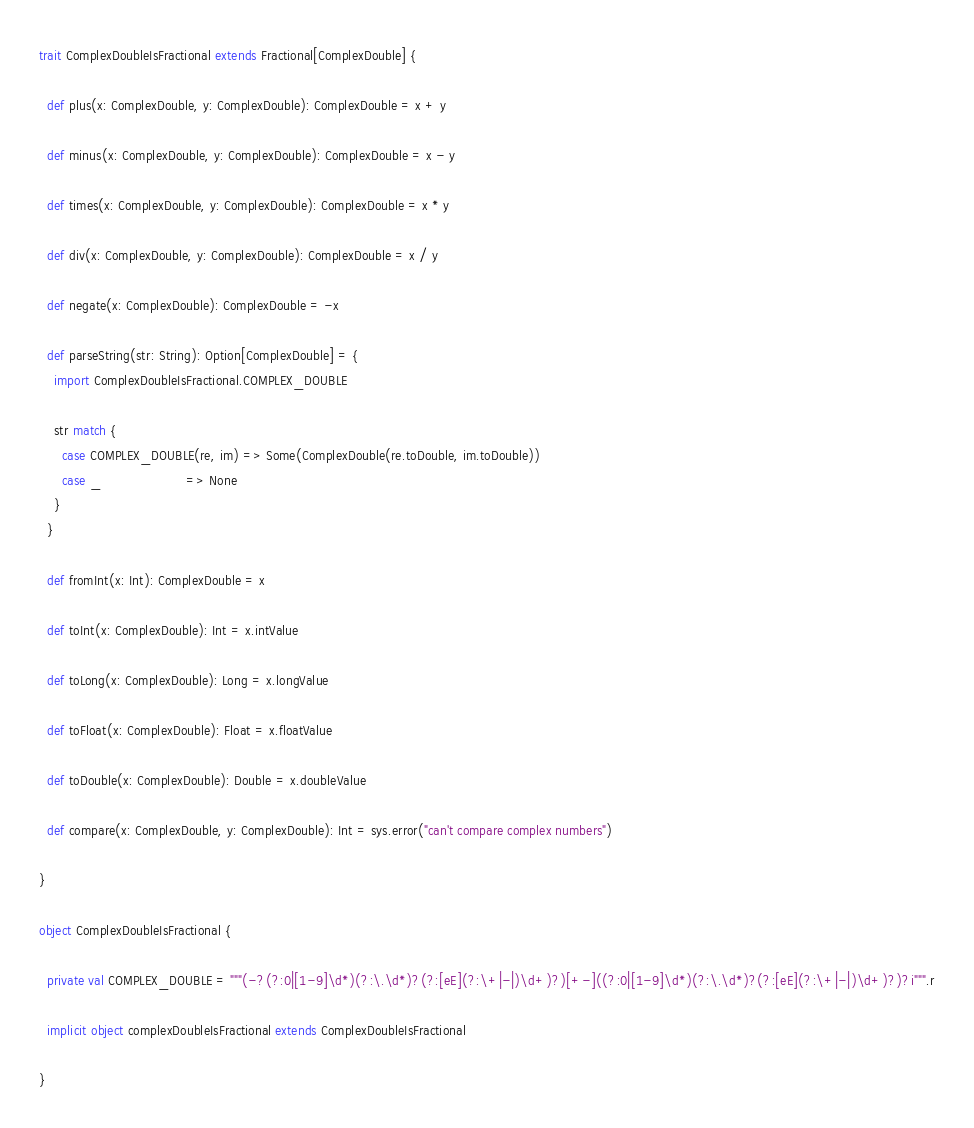<code> <loc_0><loc_0><loc_500><loc_500><_Scala_>trait ComplexDoubleIsFractional extends Fractional[ComplexDouble] {

  def plus(x: ComplexDouble, y: ComplexDouble): ComplexDouble = x + y

  def minus(x: ComplexDouble, y: ComplexDouble): ComplexDouble = x - y

  def times(x: ComplexDouble, y: ComplexDouble): ComplexDouble = x * y

  def div(x: ComplexDouble, y: ComplexDouble): ComplexDouble = x / y

  def negate(x: ComplexDouble): ComplexDouble = -x

  def parseString(str: String): Option[ComplexDouble] = {
    import ComplexDoubleIsFractional.COMPLEX_DOUBLE

    str match {
      case COMPLEX_DOUBLE(re, im) => Some(ComplexDouble(re.toDouble, im.toDouble))
      case _                      => None
    }
  }

  def fromInt(x: Int): ComplexDouble = x

  def toInt(x: ComplexDouble): Int = x.intValue

  def toLong(x: ComplexDouble): Long = x.longValue

  def toFloat(x: ComplexDouble): Float = x.floatValue

  def toDouble(x: ComplexDouble): Double = x.doubleValue

  def compare(x: ComplexDouble, y: ComplexDouble): Int = sys.error("can't compare complex numbers")

}

object ComplexDoubleIsFractional {

  private val COMPLEX_DOUBLE = """(-?(?:0|[1-9]\d*)(?:\.\d*)?(?:[eE](?:\+|-|)\d+)?)[+-]((?:0|[1-9]\d*)(?:\.\d*)?(?:[eE](?:\+|-|)\d+)?)?i""".r

  implicit object complexDoubleIsFractional extends ComplexDoubleIsFractional

}
</code> 